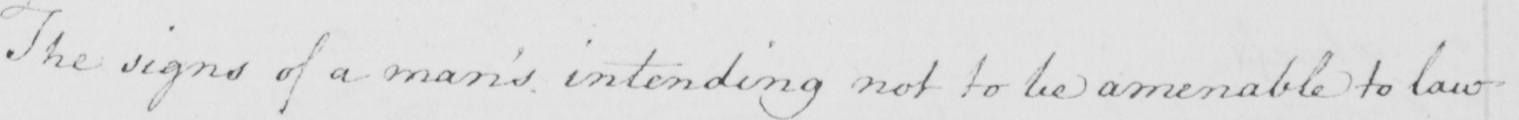Please transcribe the handwritten text in this image. The signs of a man ' s intending not to be amenable to law 